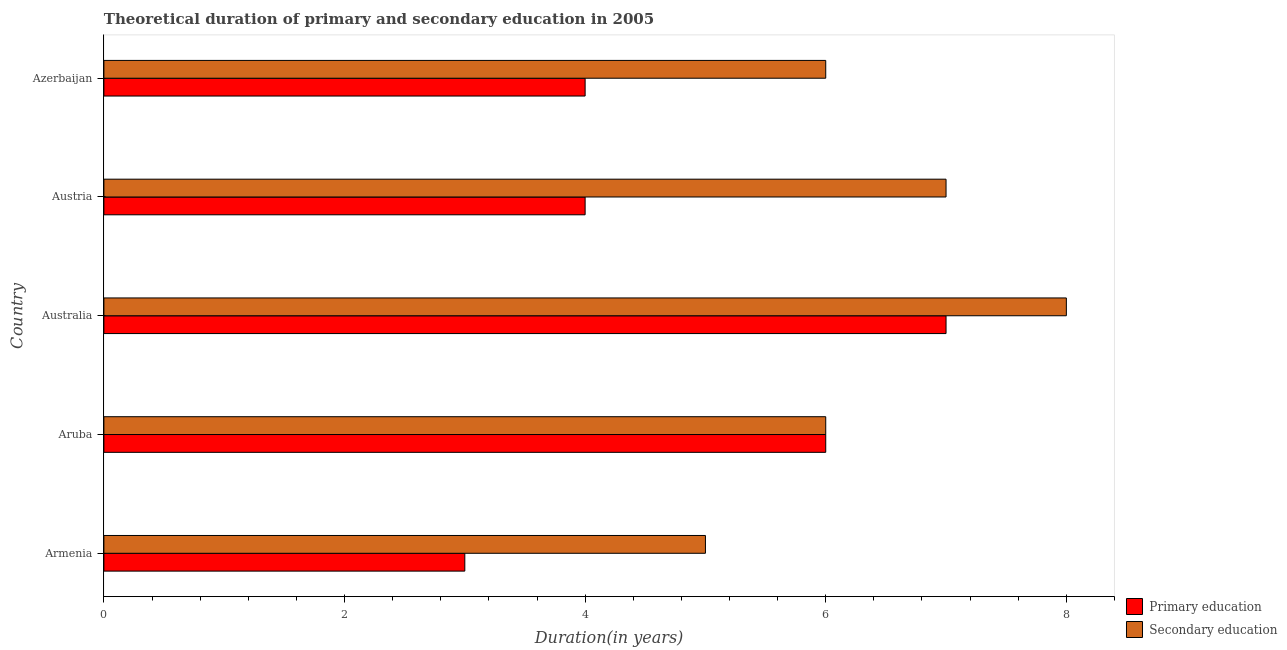Are the number of bars on each tick of the Y-axis equal?
Your answer should be compact. Yes. How many bars are there on the 4th tick from the top?
Ensure brevity in your answer.  2. How many bars are there on the 1st tick from the bottom?
Your answer should be compact. 2. What is the label of the 2nd group of bars from the top?
Your response must be concise. Austria. What is the duration of secondary education in Australia?
Offer a very short reply. 8. Across all countries, what is the maximum duration of primary education?
Offer a terse response. 7. Across all countries, what is the minimum duration of primary education?
Offer a terse response. 3. In which country was the duration of primary education minimum?
Your answer should be compact. Armenia. What is the total duration of secondary education in the graph?
Provide a short and direct response. 32. What is the difference between the duration of secondary education in Armenia and that in Australia?
Keep it short and to the point. -3. What is the difference between the duration of secondary education in Austria and the duration of primary education in Armenia?
Your answer should be compact. 4. What is the difference between the duration of primary education and duration of secondary education in Azerbaijan?
Your answer should be very brief. -2. What is the ratio of the duration of secondary education in Armenia to that in Aruba?
Offer a very short reply. 0.83. Is the duration of primary education in Armenia less than that in Australia?
Offer a very short reply. Yes. What is the difference between the highest and the second highest duration of primary education?
Give a very brief answer. 1. What is the difference between the highest and the lowest duration of primary education?
Keep it short and to the point. 4. What does the 1st bar from the top in Azerbaijan represents?
Give a very brief answer. Secondary education. How many bars are there?
Provide a succinct answer. 10. Are all the bars in the graph horizontal?
Offer a very short reply. Yes. Are the values on the major ticks of X-axis written in scientific E-notation?
Your response must be concise. No. Where does the legend appear in the graph?
Make the answer very short. Bottom right. What is the title of the graph?
Provide a succinct answer. Theoretical duration of primary and secondary education in 2005. What is the label or title of the X-axis?
Ensure brevity in your answer.  Duration(in years). What is the label or title of the Y-axis?
Your response must be concise. Country. What is the Duration(in years) in Secondary education in Aruba?
Ensure brevity in your answer.  6. What is the Duration(in years) of Secondary education in Austria?
Your response must be concise. 7. What is the Duration(in years) in Secondary education in Azerbaijan?
Your answer should be compact. 6. Across all countries, what is the maximum Duration(in years) in Secondary education?
Give a very brief answer. 8. Across all countries, what is the minimum Duration(in years) of Primary education?
Offer a terse response. 3. What is the total Duration(in years) in Primary education in the graph?
Provide a short and direct response. 24. What is the total Duration(in years) of Secondary education in the graph?
Provide a succinct answer. 32. What is the difference between the Duration(in years) in Primary education in Armenia and that in Aruba?
Give a very brief answer. -3. What is the difference between the Duration(in years) of Primary education in Armenia and that in Australia?
Give a very brief answer. -4. What is the difference between the Duration(in years) in Primary education in Armenia and that in Azerbaijan?
Give a very brief answer. -1. What is the difference between the Duration(in years) in Secondary education in Aruba and that in Austria?
Offer a terse response. -1. What is the difference between the Duration(in years) in Primary education in Australia and that in Azerbaijan?
Provide a succinct answer. 3. What is the difference between the Duration(in years) of Primary education in Austria and that in Azerbaijan?
Provide a succinct answer. 0. What is the difference between the Duration(in years) in Secondary education in Austria and that in Azerbaijan?
Offer a very short reply. 1. What is the difference between the Duration(in years) of Primary education in Armenia and the Duration(in years) of Secondary education in Aruba?
Your response must be concise. -3. What is the difference between the Duration(in years) in Primary education in Armenia and the Duration(in years) in Secondary education in Azerbaijan?
Offer a terse response. -3. What is the difference between the Duration(in years) of Primary education in Aruba and the Duration(in years) of Secondary education in Australia?
Ensure brevity in your answer.  -2. What is the difference between the Duration(in years) in Primary education in Aruba and the Duration(in years) in Secondary education in Austria?
Provide a succinct answer. -1. What is the difference between the Duration(in years) of Primary education in Australia and the Duration(in years) of Secondary education in Azerbaijan?
Give a very brief answer. 1. What is the average Duration(in years) of Secondary education per country?
Offer a very short reply. 6.4. What is the difference between the Duration(in years) in Primary education and Duration(in years) in Secondary education in Armenia?
Your response must be concise. -2. What is the difference between the Duration(in years) of Primary education and Duration(in years) of Secondary education in Aruba?
Your response must be concise. 0. What is the difference between the Duration(in years) of Primary education and Duration(in years) of Secondary education in Australia?
Ensure brevity in your answer.  -1. What is the difference between the Duration(in years) in Primary education and Duration(in years) in Secondary education in Austria?
Ensure brevity in your answer.  -3. What is the ratio of the Duration(in years) of Primary education in Armenia to that in Aruba?
Keep it short and to the point. 0.5. What is the ratio of the Duration(in years) in Primary education in Armenia to that in Australia?
Offer a terse response. 0.43. What is the ratio of the Duration(in years) of Primary education in Armenia to that in Azerbaijan?
Ensure brevity in your answer.  0.75. What is the ratio of the Duration(in years) in Primary education in Aruba to that in Australia?
Offer a very short reply. 0.86. What is the ratio of the Duration(in years) in Primary education in Aruba to that in Austria?
Your response must be concise. 1.5. What is the ratio of the Duration(in years) of Secondary education in Aruba to that in Austria?
Your response must be concise. 0.86. What is the ratio of the Duration(in years) in Primary education in Aruba to that in Azerbaijan?
Offer a terse response. 1.5. What is the ratio of the Duration(in years) of Secondary education in Australia to that in Austria?
Your answer should be very brief. 1.14. What is the ratio of the Duration(in years) in Primary education in Australia to that in Azerbaijan?
Ensure brevity in your answer.  1.75. What is the ratio of the Duration(in years) of Secondary education in Australia to that in Azerbaijan?
Ensure brevity in your answer.  1.33. What is the ratio of the Duration(in years) of Secondary education in Austria to that in Azerbaijan?
Give a very brief answer. 1.17. What is the difference between the highest and the second highest Duration(in years) of Secondary education?
Make the answer very short. 1. 